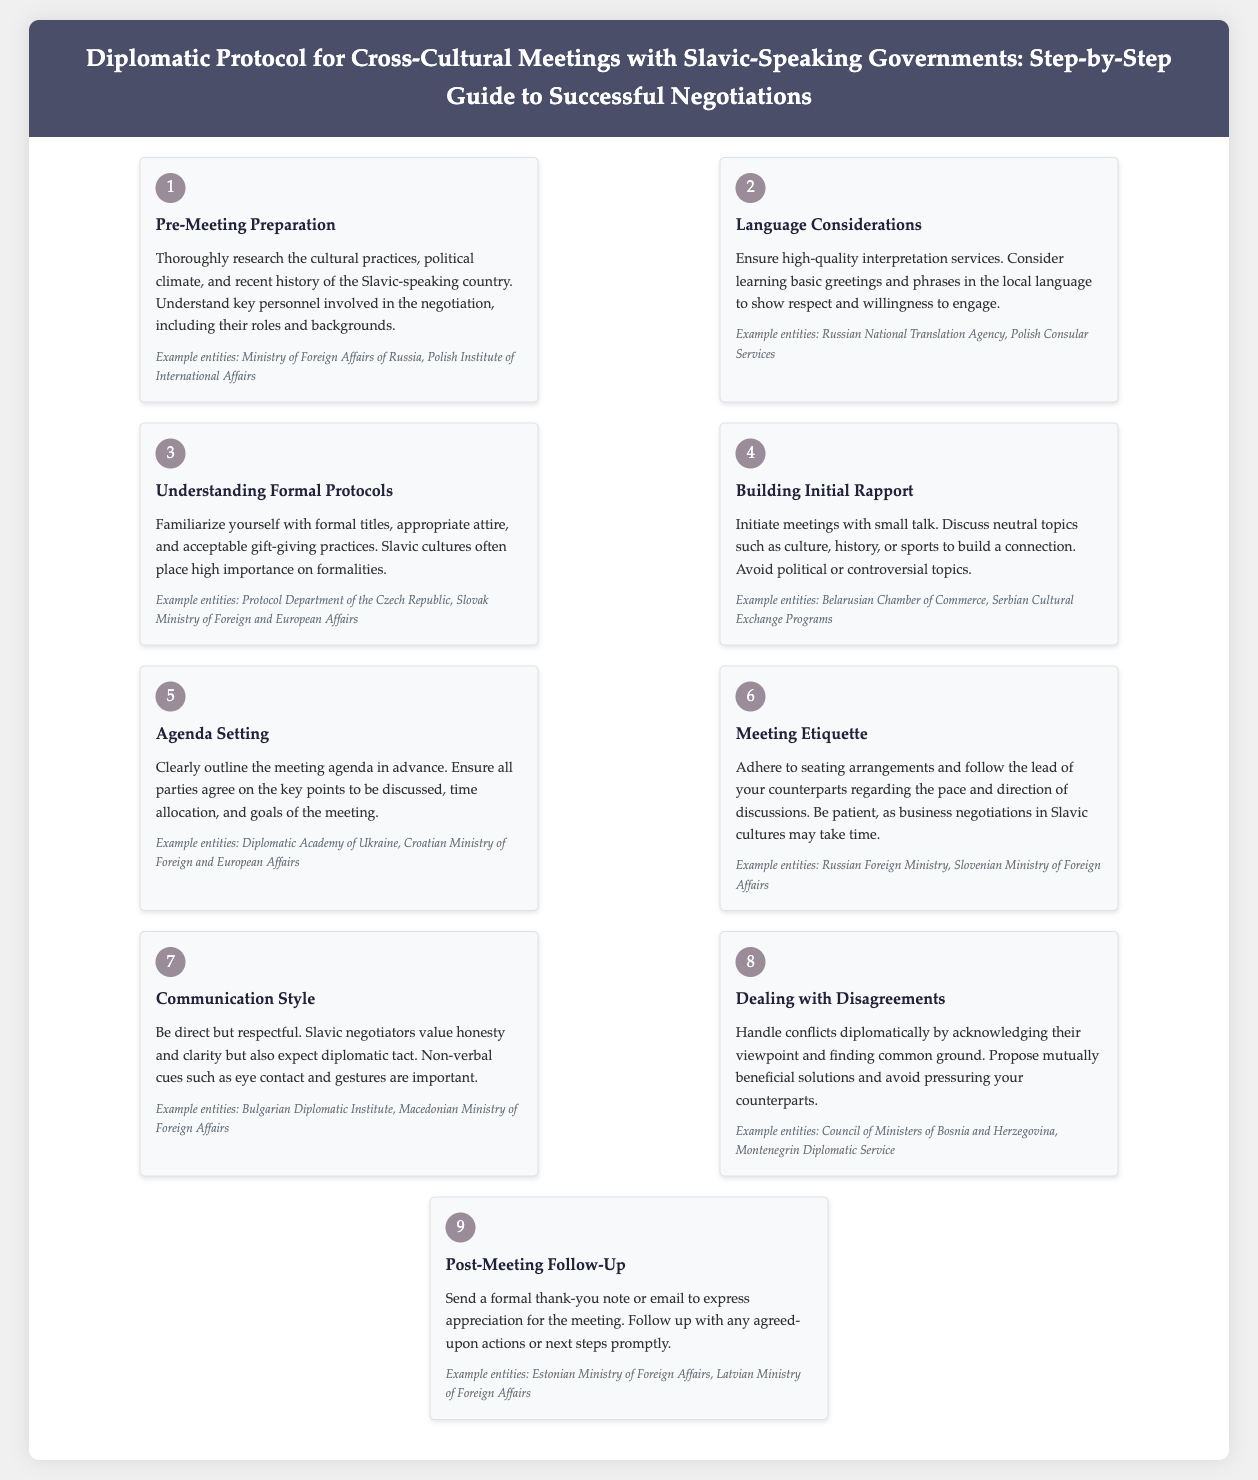What is the first step in the guide? The first step in the guide is described as "Pre-Meeting Preparation," which involves researching cultural practices and political climate.
Answer: Pre-Meeting Preparation What should you ensure for language considerations? The guide states that you should ensure high-quality interpretation services.
Answer: High-quality interpretation services What is advised regarding gift-giving practices? The document emphasizes that understanding acceptable gift-giving practices is important, as Slavic cultures place high importance on formalities.
Answer: Acceptable gift-giving practices How should you initiate meetings? According to the guide, you should initiate meetings with small talk and discuss neutral topics.
Answer: Small talk What is the recommended approach for handling disagreements? The guide suggests acknowledging the other viewpoint and finding common ground.
Answer: Acknowledging their viewpoint Which example entities are associated with post-meeting follow-up? The document lists the Estonian Ministry of Foreign Affairs and Latvian Ministry of Foreign Affairs as example entities for post-meeting follow-up.
Answer: Estonian Ministry of Foreign Affairs, Latvian Ministry of Foreign Affairs What should you do after the meeting? The document advises sending a formal thank-you note or email after the meeting.
Answer: Send a formal thank-you note Why is understanding formal protocols emphasized? It is emphasized because Slavic cultures often place high importance on formalities.
Answer: High importance on formalities What does the document state about communication style? It states to be direct but respectful, valuing honesty and clarity in discussions.
Answer: Direct but respectful 